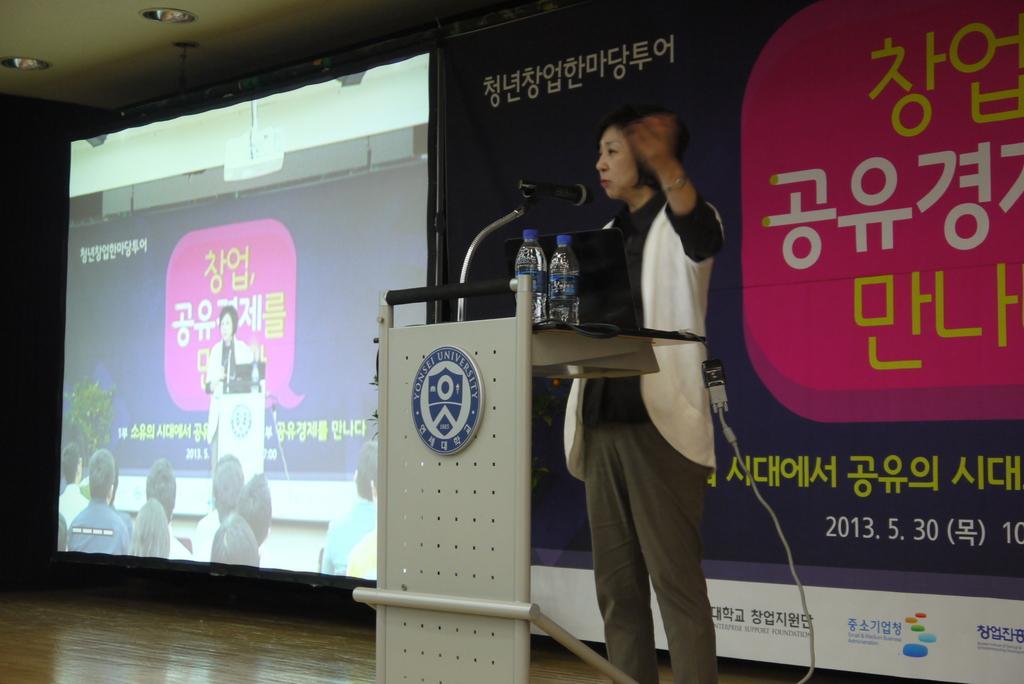Can you describe this image briefly? Here we can see a woman standing near the speech desk with microphone to it, speaking to audience and beside her we can see a digital screen and at the right side we can see a banner and there are couple of bottles placed on the speech desk 